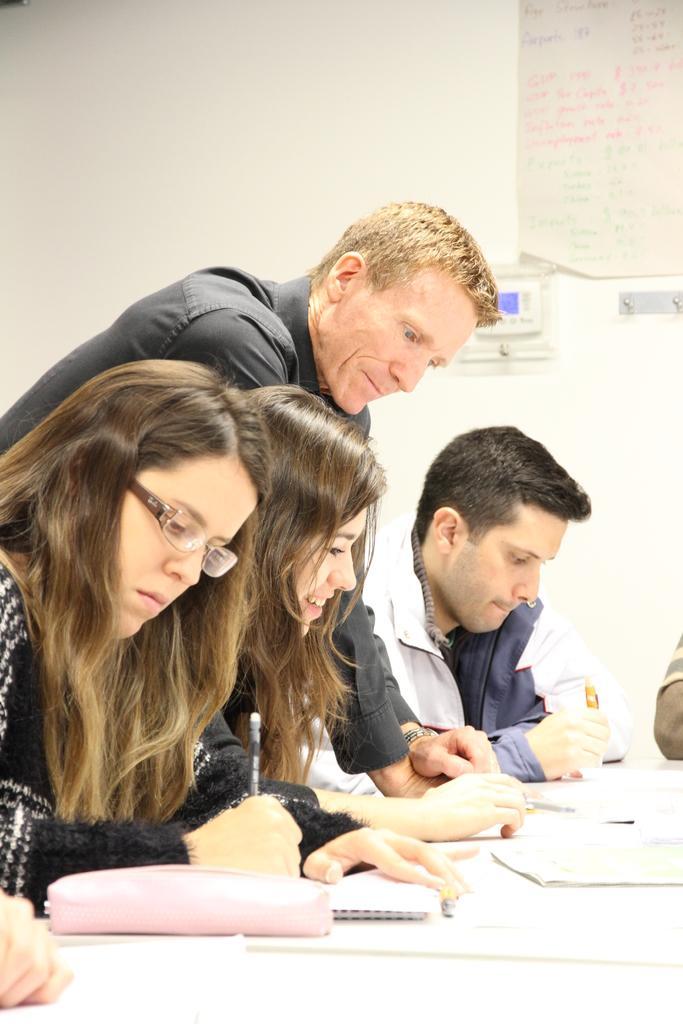Could you give a brief overview of what you see in this image? This image is clicked inside a room. There are four people in this image. Three are sitting and one person is standing. In the background, there is a wall on which charts are pasted. In the front there is table on which, purse , books and pens are kept. To the left, the woman is wearing black dress. To the right, the man is wearing white jacket. 